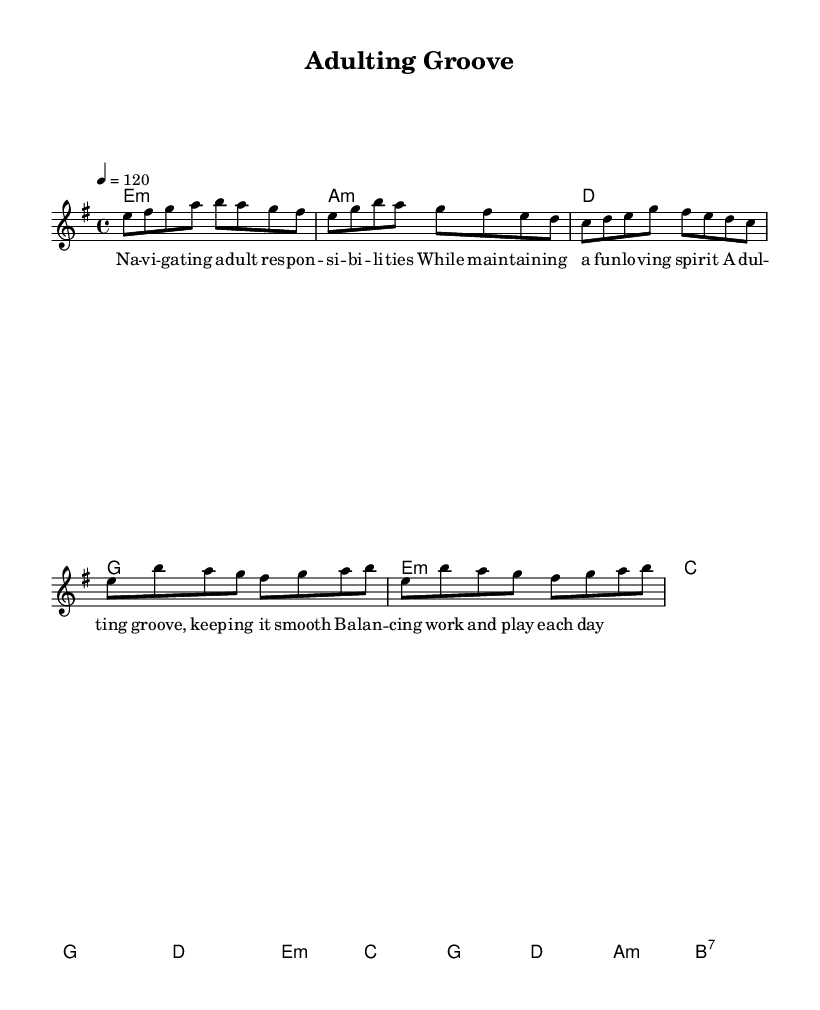What is the key signature of this music? The key signature shown in the music indicates E minor, which has one sharp (F#) and is typically the relative minor of G major. This can be identified at the beginning of the score.
Answer: E minor What is the time signature of this piece? The time signature is indicated as 4/4, meaning there are four beats in every measure and the quarter note receives one beat. This is found at the start of the sheet music.
Answer: 4/4 What is the tempo marking for this piece? The tempo marking is shown as a quarter note equals 120, meaning the piece should be played at a speed of 120 beats per minute. This is located under the global settings in the score.
Answer: 120 How many measures are in the chorus section? By analyzing the chorus section in the sheet music, we find it consists of four measures, as indicated by the grouping of the notes and chords.
Answer: 4 What is the overall theme reflected in the lyrics? The lyrics of this piece express the theme of navigating adult responsibilities while maintaining a joyful spirit, providing insights into the challenges of adulthood. This can be inferred by reading the lyrics closely.
Answer: Navigating adult responsibilities What types of chords are predominantly used in the harmony? The harmony section predominantly features minor and major chords, typical in funk music. This is recognizable as the chords include variations like E minor, A minor, and B7, which complement the lively characteristics of the genre.
Answer: Minor and major chords What musical genre does this piece represent? This piece blends disco and funk elements, which is evident through the rhythmic structure, tempo, and groove present in the melody and harmony, making it easily identifiable as disco-funk fusion.
Answer: Disco-funk fusion 